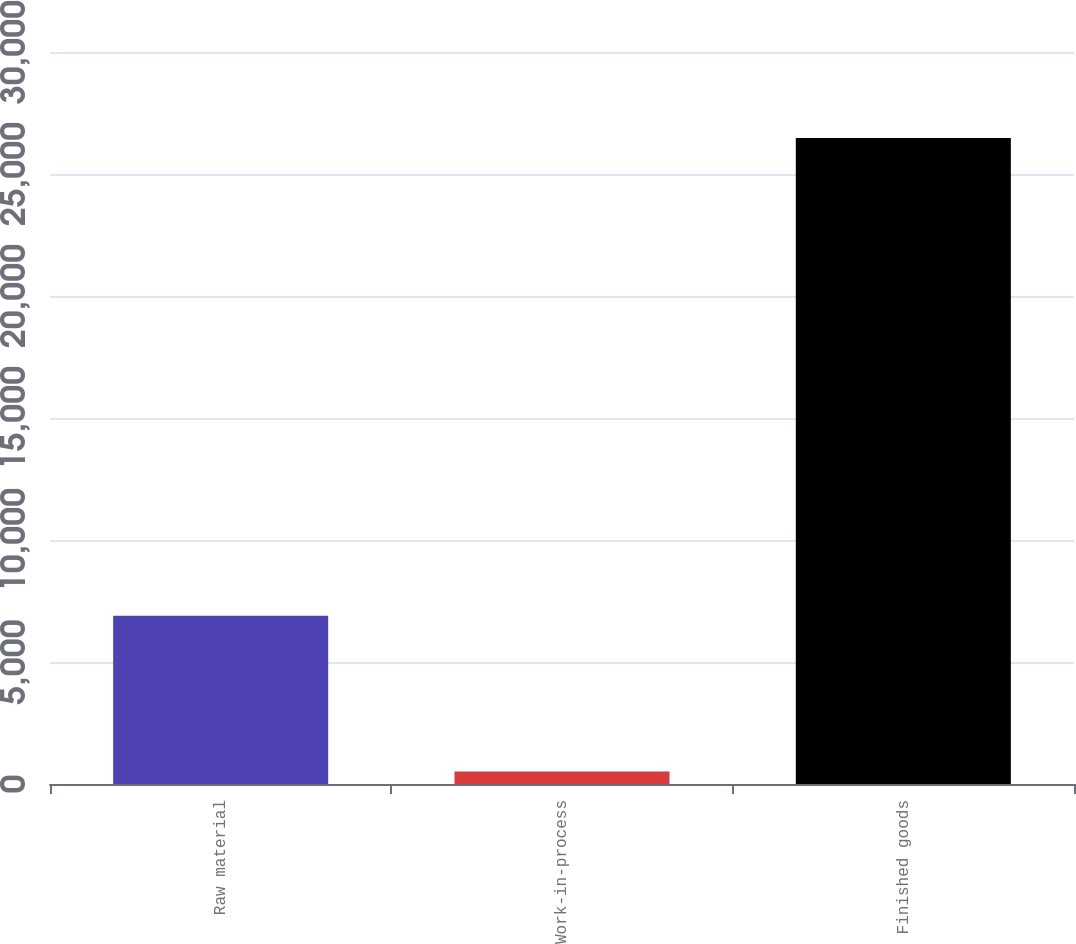Convert chart to OTSL. <chart><loc_0><loc_0><loc_500><loc_500><bar_chart><fcel>Raw material<fcel>Work-in-process<fcel>Finished goods<nl><fcel>6891<fcel>509<fcel>26474<nl></chart> 